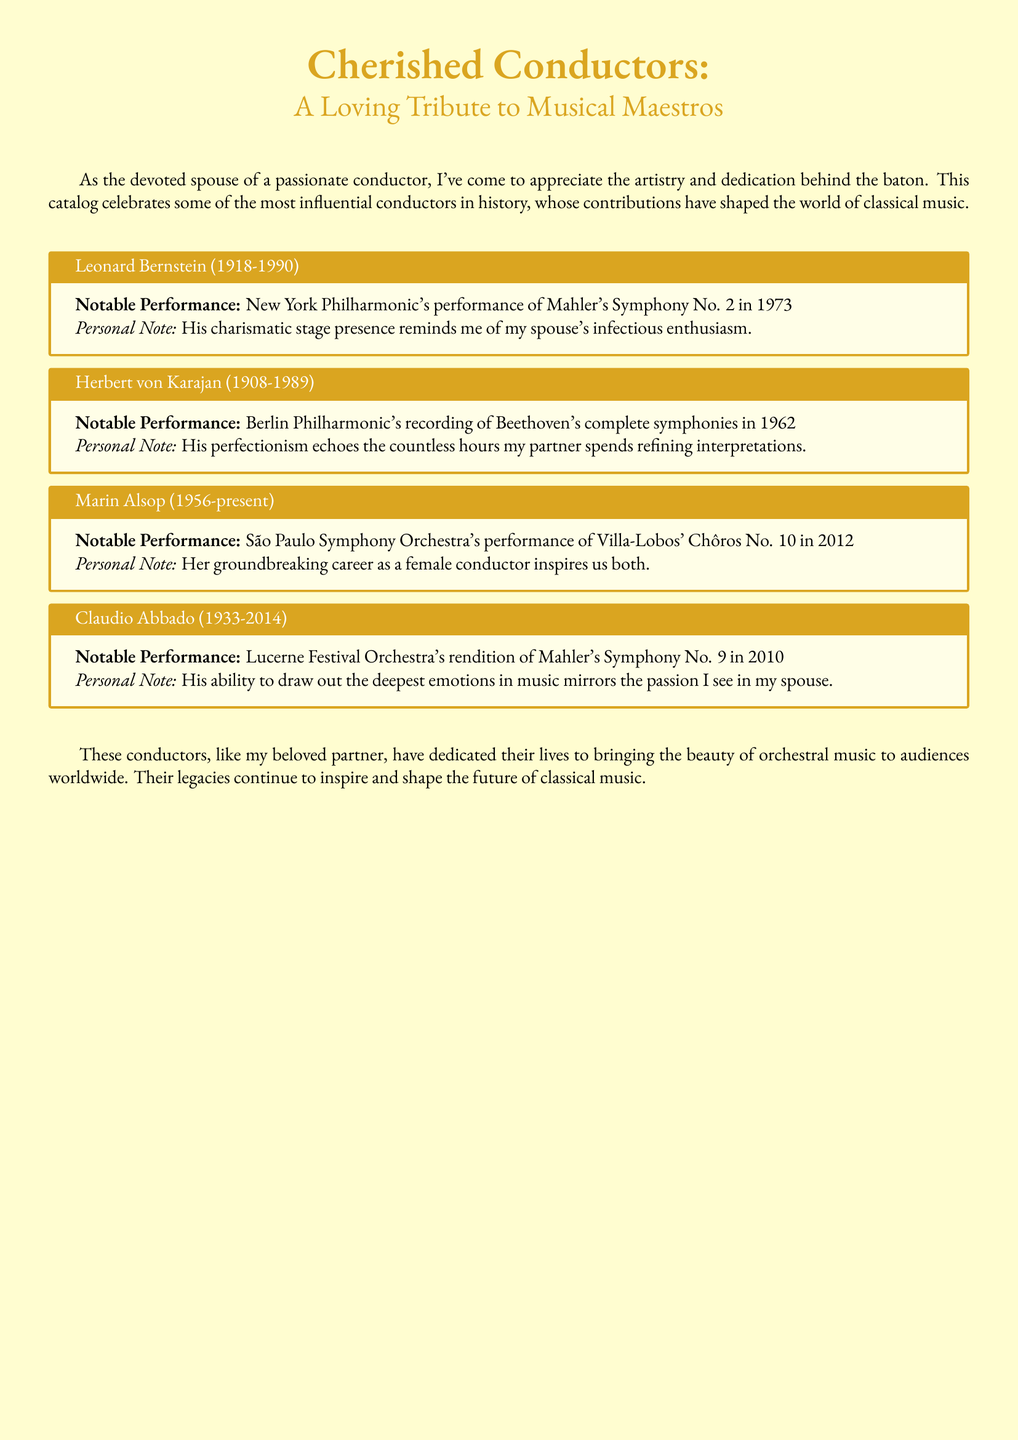What years did Leonard Bernstein live? The document provides the lifespan of Leonard Bernstein, which is 1918 to 1990.
Answer: 1918-1990 What is a notable performance of Herbert von Karajan? The document states that Herbert von Karajan's notable performance was the recording of Beethoven's complete symphonies in 1962.
Answer: Beethoven's complete symphonies in 1962 Who performed Villa-Lobos' Chôros No. 10 in 2012? According to the document, the São Paulo Symphony Orchestra performed Villa-Lobos' Chôros No. 10 in 2012.
Answer: São Paulo Symphony Orchestra Which conductor's personal note relates to a groundbreaking career as a female conductor? The document attributes this personal note to Marin Alsop.
Answer: Marin Alsop What emotional aspect does Claudio Abbado's conducting reflect? The document mentions that Claudio Abbado draws out the deepest emotions in music.
Answer: Deepest emotions in music What color is used for the document's background? The document specifies that the background color is scorepaper, registered as an RGB value.
Answer: Scorepaper How many conductors are featured in the document? The document lists four conductors, totaling this number.
Answer: Four What performance did Leonard Bernstein conduct with the New York Philharmonic? It states that Bernstein conducted Mahler's Symphony No. 2 with the New York Philharmonic in 1973.
Answer: Mahler's Symphony No. 2 in 1973 